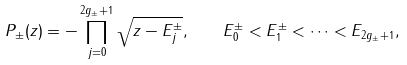Convert formula to latex. <formula><loc_0><loc_0><loc_500><loc_500>P _ { \pm } ( z ) = - \prod _ { j = 0 } ^ { 2 g _ { \pm } + 1 } \sqrt { z - E _ { j } ^ { \pm } } , \quad E _ { 0 } ^ { \pm } < E _ { 1 } ^ { \pm } < \cdots < E _ { 2 g _ { \pm } + 1 } ,</formula> 